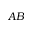<formula> <loc_0><loc_0><loc_500><loc_500>A B</formula> 